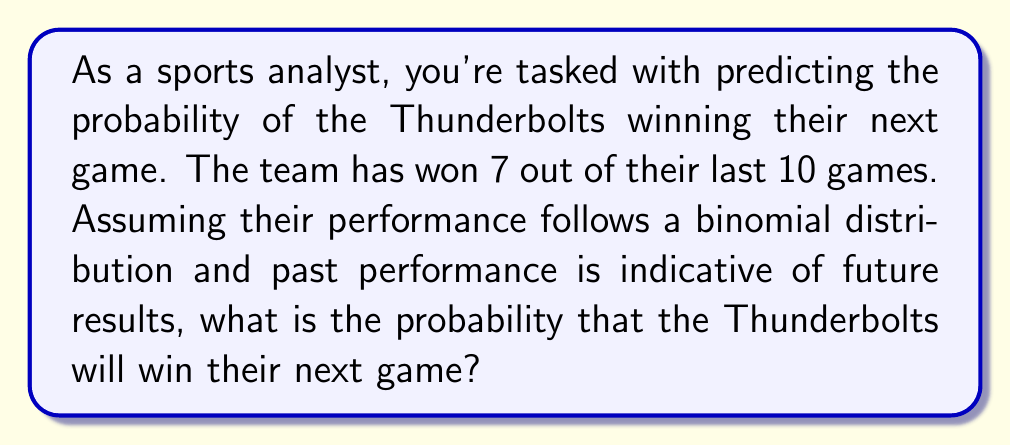Could you help me with this problem? To solve this problem, we'll use the concept of maximum likelihood estimation from statistical mechanics. Here's the step-by-step approach:

1) In a binomial distribution, the probability of success (p) is estimated by the proportion of successes in the observed data.

2) The Thunderbolts won 7 out of 10 games, so our maximum likelihood estimate for p is:

   $$p = \frac{\text{number of wins}}{\text{total number of games}} = \frac{7}{10} = 0.7$$

3) This estimate of p represents the probability of the Thunderbolts winning any single game based on their recent performance.

4) Therefore, the probability of winning the next game is also 0.7 or 70%.

5) It's important to note that this is a simplified model. In reality, many other factors could influence the outcome of a game, such as injuries, home/away status, or opponent strength. However, this basic model provides a quick and straightforward estimate based on recent performance.
Answer: 0.7 or 70% 